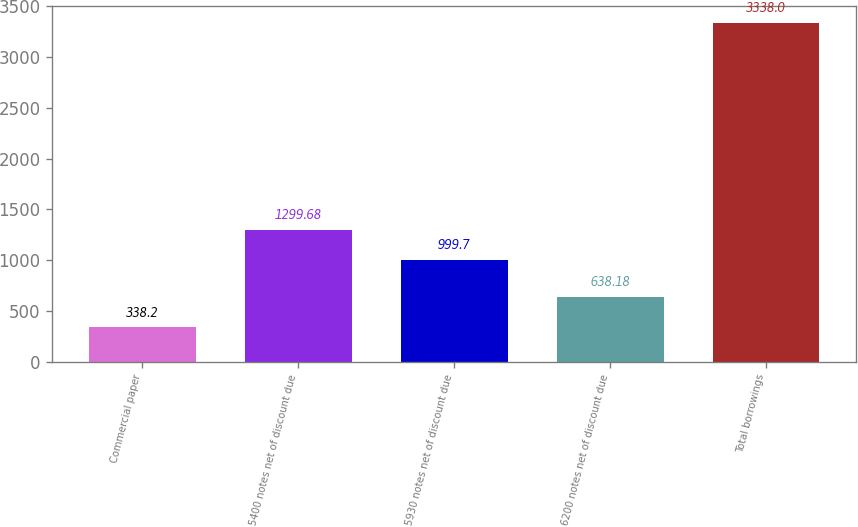<chart> <loc_0><loc_0><loc_500><loc_500><bar_chart><fcel>Commercial paper<fcel>5400 notes net of discount due<fcel>5930 notes net of discount due<fcel>6200 notes net of discount due<fcel>Total borrowings<nl><fcel>338.2<fcel>1299.68<fcel>999.7<fcel>638.18<fcel>3338<nl></chart> 